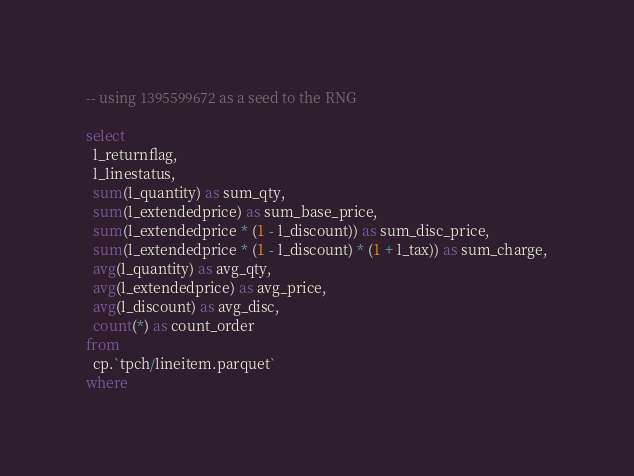<code> <loc_0><loc_0><loc_500><loc_500><_SQL_>-- using 1395599672 as a seed to the RNG

select
  l_returnflag,
  l_linestatus,
  sum(l_quantity) as sum_qty,
  sum(l_extendedprice) as sum_base_price,
  sum(l_extendedprice * (1 - l_discount)) as sum_disc_price,
  sum(l_extendedprice * (1 - l_discount) * (1 + l_tax)) as sum_charge,
  avg(l_quantity) as avg_qty,
  avg(l_extendedprice) as avg_price,
  avg(l_discount) as avg_disc,
  count(*) as count_order
from
  cp.`tpch/lineitem.parquet`
where</code> 